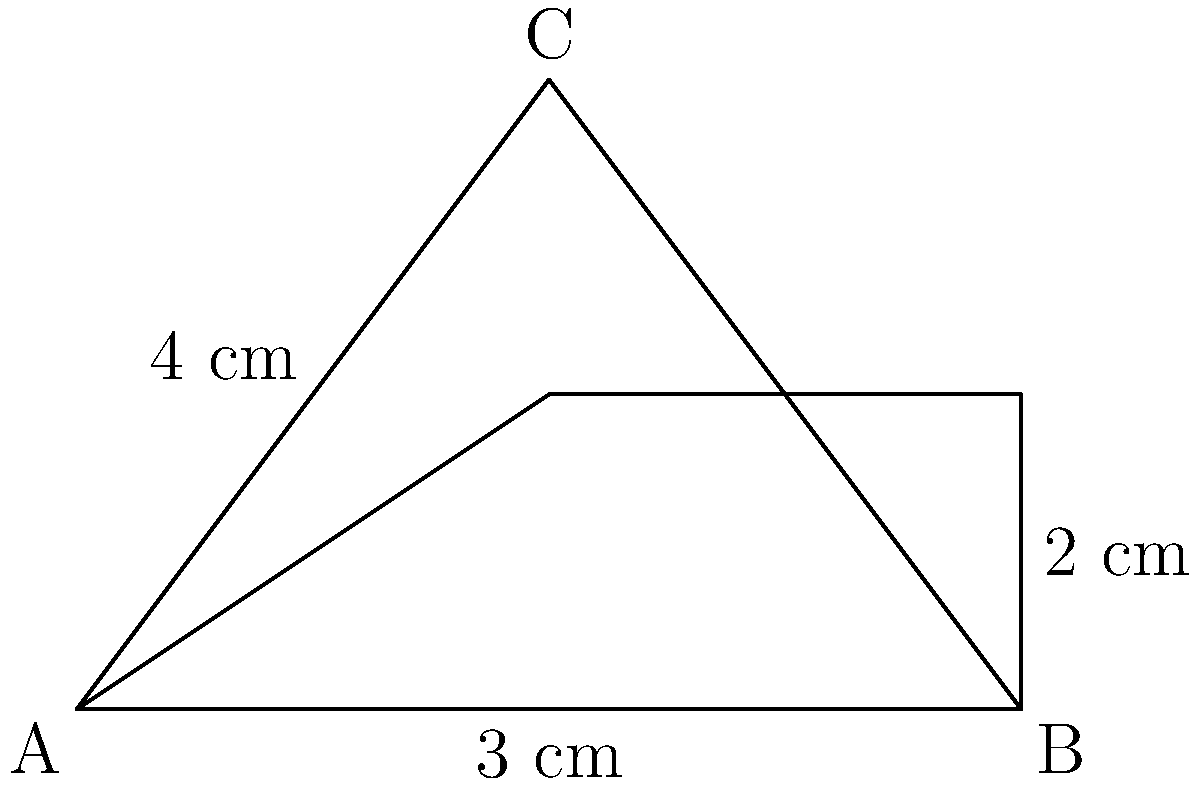A triangular warning label on a vape product package has a base of 6 cm and a height of 4 cm. If a horizontal line is drawn 2 cm from the base, parallel to it, what is the area of the upper (smaller) triangle formed? Let's approach this step-by-step:

1) First, we need to understand that the horizontal line creates two similar triangles.

2) The ratio of the heights of these triangles is 2:4 or 1:2.

3) Since the triangles are similar, their bases will also be in the same ratio.

4) Let the base of the smaller triangle be $x$ cm. Then:
   $\frac{x}{6} = \frac{2}{4} = \frac{1}{2}$

5) Solving for $x$:
   $x = 6 \cdot \frac{1}{2} = 3$ cm

6) Now we have the dimensions of the smaller triangle:
   Base = 3 cm
   Height = 2 cm

7) The area of a triangle is given by the formula: $A = \frac{1}{2} \cdot base \cdot height$

8) Substituting our values:
   $A = \frac{1}{2} \cdot 3 \cdot 2 = 3$ sq cm

Therefore, the area of the upper (smaller) triangle is 3 square centimeters.
Answer: 3 sq cm 